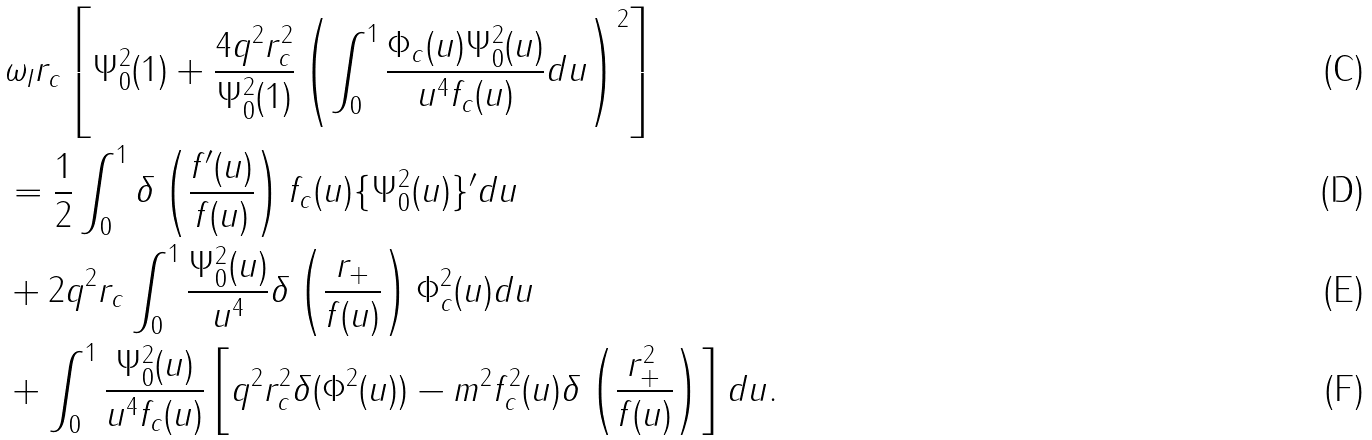Convert formula to latex. <formula><loc_0><loc_0><loc_500><loc_500>& \omega _ { I } r _ { c } \left [ \Psi _ { 0 } ^ { 2 } ( 1 ) + \frac { 4 q ^ { 2 } r _ { c } ^ { 2 } } { \Psi _ { 0 } ^ { 2 } ( 1 ) } \left ( \int ^ { 1 } _ { 0 } \frac { \Phi _ { c } ( u ) \Psi _ { 0 } ^ { 2 } ( u ) } { u ^ { 4 } f _ { c } ( u ) } d u \right ) ^ { 2 } \right ] \\ & = \frac { 1 } { 2 } \int ^ { 1 } _ { 0 } \delta \left ( \frac { f ^ { \prime } ( u ) } { f ( u ) } \right ) f _ { c } ( u ) \{ \Psi ^ { 2 } _ { 0 } ( u ) \} ^ { \prime } d u \\ & + 2 q ^ { 2 } r _ { c } \int ^ { 1 } _ { 0 } \frac { \Psi _ { 0 } ^ { 2 } ( u ) } { u ^ { 4 } } \delta \left ( \frac { r _ { + } } { f ( u ) } \right ) \Phi _ { c } ^ { 2 } ( u ) d u \\ & + \int ^ { 1 } _ { 0 } \frac { \Psi _ { 0 } ^ { 2 } ( u ) } { u ^ { 4 } f _ { c } ( u ) } \left [ q ^ { 2 } r _ { c } ^ { 2 } \delta ( \Phi ^ { 2 } ( u ) ) - m ^ { 2 } f _ { c } ^ { 2 } ( u ) \delta \left ( \frac { r _ { + } ^ { 2 } } { f ( u ) } \right ) \right ] d u .</formula> 